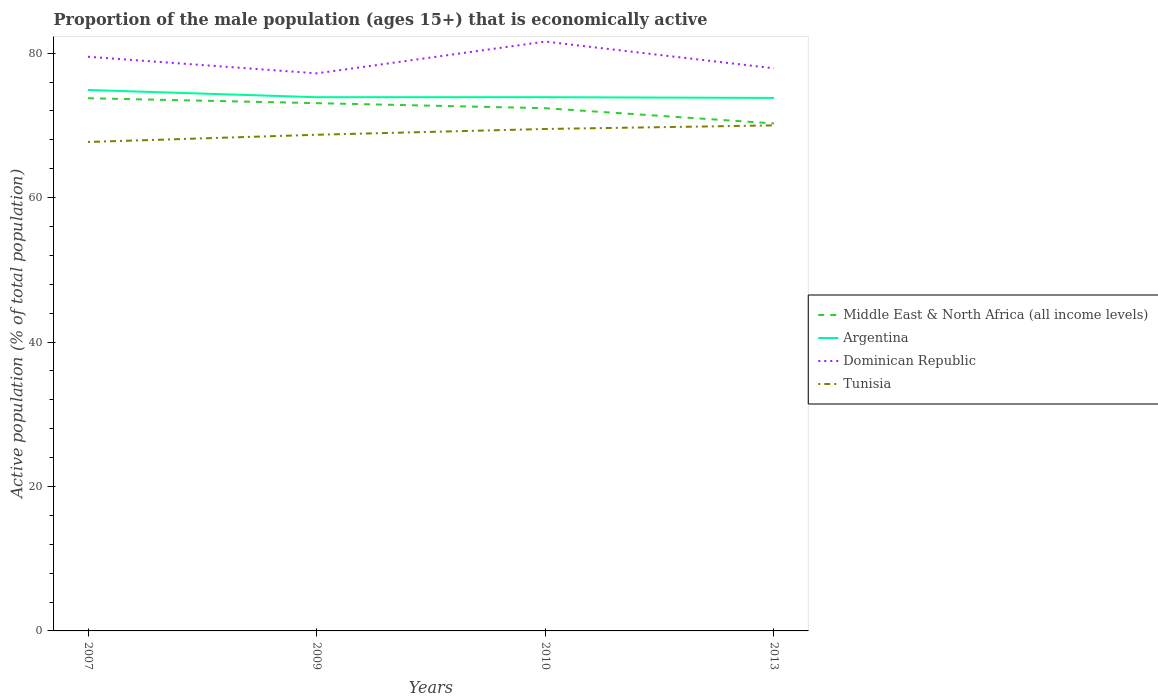How many different coloured lines are there?
Give a very brief answer. 4. Does the line corresponding to Middle East & North Africa (all income levels) intersect with the line corresponding to Tunisia?
Keep it short and to the point. No. Across all years, what is the maximum proportion of the male population that is economically active in Dominican Republic?
Ensure brevity in your answer.  77.2. In which year was the proportion of the male population that is economically active in Middle East & North Africa (all income levels) maximum?
Make the answer very short. 2013. What is the total proportion of the male population that is economically active in Dominican Republic in the graph?
Provide a short and direct response. -2.1. What is the difference between the highest and the second highest proportion of the male population that is economically active in Dominican Republic?
Make the answer very short. 4.4. How many lines are there?
Give a very brief answer. 4. Are the values on the major ticks of Y-axis written in scientific E-notation?
Keep it short and to the point. No. Does the graph contain any zero values?
Ensure brevity in your answer.  No. Does the graph contain grids?
Make the answer very short. No. Where does the legend appear in the graph?
Provide a short and direct response. Center right. How are the legend labels stacked?
Your response must be concise. Vertical. What is the title of the graph?
Keep it short and to the point. Proportion of the male population (ages 15+) that is economically active. Does "Syrian Arab Republic" appear as one of the legend labels in the graph?
Provide a short and direct response. No. What is the label or title of the Y-axis?
Make the answer very short. Active population (% of total population). What is the Active population (% of total population) of Middle East & North Africa (all income levels) in 2007?
Offer a very short reply. 73.76. What is the Active population (% of total population) of Argentina in 2007?
Make the answer very short. 74.9. What is the Active population (% of total population) of Dominican Republic in 2007?
Make the answer very short. 79.5. What is the Active population (% of total population) of Tunisia in 2007?
Make the answer very short. 67.7. What is the Active population (% of total population) in Middle East & North Africa (all income levels) in 2009?
Make the answer very short. 73.08. What is the Active population (% of total population) of Argentina in 2009?
Provide a short and direct response. 73.9. What is the Active population (% of total population) of Dominican Republic in 2009?
Offer a very short reply. 77.2. What is the Active population (% of total population) in Tunisia in 2009?
Provide a short and direct response. 68.7. What is the Active population (% of total population) of Middle East & North Africa (all income levels) in 2010?
Ensure brevity in your answer.  72.38. What is the Active population (% of total population) of Argentina in 2010?
Keep it short and to the point. 73.9. What is the Active population (% of total population) in Dominican Republic in 2010?
Your response must be concise. 81.6. What is the Active population (% of total population) in Tunisia in 2010?
Your response must be concise. 69.5. What is the Active population (% of total population) in Middle East & North Africa (all income levels) in 2013?
Offer a very short reply. 70.27. What is the Active population (% of total population) in Argentina in 2013?
Offer a very short reply. 73.8. What is the Active population (% of total population) in Dominican Republic in 2013?
Your response must be concise. 77.9. Across all years, what is the maximum Active population (% of total population) in Middle East & North Africa (all income levels)?
Your answer should be compact. 73.76. Across all years, what is the maximum Active population (% of total population) of Argentina?
Provide a short and direct response. 74.9. Across all years, what is the maximum Active population (% of total population) in Dominican Republic?
Your response must be concise. 81.6. Across all years, what is the minimum Active population (% of total population) in Middle East & North Africa (all income levels)?
Your answer should be compact. 70.27. Across all years, what is the minimum Active population (% of total population) in Argentina?
Offer a terse response. 73.8. Across all years, what is the minimum Active population (% of total population) of Dominican Republic?
Make the answer very short. 77.2. Across all years, what is the minimum Active population (% of total population) in Tunisia?
Make the answer very short. 67.7. What is the total Active population (% of total population) of Middle East & North Africa (all income levels) in the graph?
Provide a short and direct response. 289.48. What is the total Active population (% of total population) of Argentina in the graph?
Give a very brief answer. 296.5. What is the total Active population (% of total population) of Dominican Republic in the graph?
Keep it short and to the point. 316.2. What is the total Active population (% of total population) in Tunisia in the graph?
Provide a short and direct response. 275.9. What is the difference between the Active population (% of total population) in Middle East & North Africa (all income levels) in 2007 and that in 2009?
Your response must be concise. 0.68. What is the difference between the Active population (% of total population) of Argentina in 2007 and that in 2009?
Provide a succinct answer. 1. What is the difference between the Active population (% of total population) in Dominican Republic in 2007 and that in 2009?
Offer a terse response. 2.3. What is the difference between the Active population (% of total population) in Middle East & North Africa (all income levels) in 2007 and that in 2010?
Give a very brief answer. 1.38. What is the difference between the Active population (% of total population) of Argentina in 2007 and that in 2010?
Your answer should be very brief. 1. What is the difference between the Active population (% of total population) of Dominican Republic in 2007 and that in 2010?
Offer a very short reply. -2.1. What is the difference between the Active population (% of total population) of Middle East & North Africa (all income levels) in 2007 and that in 2013?
Provide a succinct answer. 3.49. What is the difference between the Active population (% of total population) of Argentina in 2007 and that in 2013?
Make the answer very short. 1.1. What is the difference between the Active population (% of total population) in Dominican Republic in 2007 and that in 2013?
Offer a very short reply. 1.6. What is the difference between the Active population (% of total population) in Tunisia in 2007 and that in 2013?
Offer a terse response. -2.3. What is the difference between the Active population (% of total population) of Middle East & North Africa (all income levels) in 2009 and that in 2010?
Provide a succinct answer. 0.7. What is the difference between the Active population (% of total population) in Middle East & North Africa (all income levels) in 2009 and that in 2013?
Your answer should be compact. 2.81. What is the difference between the Active population (% of total population) in Argentina in 2009 and that in 2013?
Provide a short and direct response. 0.1. What is the difference between the Active population (% of total population) of Dominican Republic in 2009 and that in 2013?
Your answer should be very brief. -0.7. What is the difference between the Active population (% of total population) in Tunisia in 2009 and that in 2013?
Keep it short and to the point. -1.3. What is the difference between the Active population (% of total population) of Middle East & North Africa (all income levels) in 2010 and that in 2013?
Offer a very short reply. 2.11. What is the difference between the Active population (% of total population) of Argentina in 2010 and that in 2013?
Your response must be concise. 0.1. What is the difference between the Active population (% of total population) of Dominican Republic in 2010 and that in 2013?
Provide a succinct answer. 3.7. What is the difference between the Active population (% of total population) of Tunisia in 2010 and that in 2013?
Your answer should be very brief. -0.5. What is the difference between the Active population (% of total population) of Middle East & North Africa (all income levels) in 2007 and the Active population (% of total population) of Argentina in 2009?
Keep it short and to the point. -0.14. What is the difference between the Active population (% of total population) of Middle East & North Africa (all income levels) in 2007 and the Active population (% of total population) of Dominican Republic in 2009?
Give a very brief answer. -3.44. What is the difference between the Active population (% of total population) of Middle East & North Africa (all income levels) in 2007 and the Active population (% of total population) of Tunisia in 2009?
Provide a succinct answer. 5.06. What is the difference between the Active population (% of total population) of Argentina in 2007 and the Active population (% of total population) of Dominican Republic in 2009?
Your answer should be very brief. -2.3. What is the difference between the Active population (% of total population) in Argentina in 2007 and the Active population (% of total population) in Tunisia in 2009?
Keep it short and to the point. 6.2. What is the difference between the Active population (% of total population) in Dominican Republic in 2007 and the Active population (% of total population) in Tunisia in 2009?
Ensure brevity in your answer.  10.8. What is the difference between the Active population (% of total population) in Middle East & North Africa (all income levels) in 2007 and the Active population (% of total population) in Argentina in 2010?
Your answer should be very brief. -0.14. What is the difference between the Active population (% of total population) of Middle East & North Africa (all income levels) in 2007 and the Active population (% of total population) of Dominican Republic in 2010?
Offer a very short reply. -7.84. What is the difference between the Active population (% of total population) of Middle East & North Africa (all income levels) in 2007 and the Active population (% of total population) of Tunisia in 2010?
Provide a succinct answer. 4.26. What is the difference between the Active population (% of total population) in Dominican Republic in 2007 and the Active population (% of total population) in Tunisia in 2010?
Provide a succinct answer. 10. What is the difference between the Active population (% of total population) in Middle East & North Africa (all income levels) in 2007 and the Active population (% of total population) in Argentina in 2013?
Give a very brief answer. -0.04. What is the difference between the Active population (% of total population) in Middle East & North Africa (all income levels) in 2007 and the Active population (% of total population) in Dominican Republic in 2013?
Keep it short and to the point. -4.14. What is the difference between the Active population (% of total population) of Middle East & North Africa (all income levels) in 2007 and the Active population (% of total population) of Tunisia in 2013?
Give a very brief answer. 3.76. What is the difference between the Active population (% of total population) of Argentina in 2007 and the Active population (% of total population) of Tunisia in 2013?
Give a very brief answer. 4.9. What is the difference between the Active population (% of total population) of Dominican Republic in 2007 and the Active population (% of total population) of Tunisia in 2013?
Make the answer very short. 9.5. What is the difference between the Active population (% of total population) in Middle East & North Africa (all income levels) in 2009 and the Active population (% of total population) in Argentina in 2010?
Provide a short and direct response. -0.82. What is the difference between the Active population (% of total population) of Middle East & North Africa (all income levels) in 2009 and the Active population (% of total population) of Dominican Republic in 2010?
Keep it short and to the point. -8.52. What is the difference between the Active population (% of total population) of Middle East & North Africa (all income levels) in 2009 and the Active population (% of total population) of Tunisia in 2010?
Provide a short and direct response. 3.58. What is the difference between the Active population (% of total population) in Argentina in 2009 and the Active population (% of total population) in Dominican Republic in 2010?
Your answer should be very brief. -7.7. What is the difference between the Active population (% of total population) of Argentina in 2009 and the Active population (% of total population) of Tunisia in 2010?
Provide a short and direct response. 4.4. What is the difference between the Active population (% of total population) of Middle East & North Africa (all income levels) in 2009 and the Active population (% of total population) of Argentina in 2013?
Keep it short and to the point. -0.72. What is the difference between the Active population (% of total population) in Middle East & North Africa (all income levels) in 2009 and the Active population (% of total population) in Dominican Republic in 2013?
Make the answer very short. -4.82. What is the difference between the Active population (% of total population) in Middle East & North Africa (all income levels) in 2009 and the Active population (% of total population) in Tunisia in 2013?
Ensure brevity in your answer.  3.08. What is the difference between the Active population (% of total population) in Argentina in 2009 and the Active population (% of total population) in Dominican Republic in 2013?
Keep it short and to the point. -4. What is the difference between the Active population (% of total population) of Middle East & North Africa (all income levels) in 2010 and the Active population (% of total population) of Argentina in 2013?
Your response must be concise. -1.42. What is the difference between the Active population (% of total population) of Middle East & North Africa (all income levels) in 2010 and the Active population (% of total population) of Dominican Republic in 2013?
Offer a very short reply. -5.52. What is the difference between the Active population (% of total population) in Middle East & North Africa (all income levels) in 2010 and the Active population (% of total population) in Tunisia in 2013?
Ensure brevity in your answer.  2.38. What is the difference between the Active population (% of total population) in Argentina in 2010 and the Active population (% of total population) in Dominican Republic in 2013?
Keep it short and to the point. -4. What is the difference between the Active population (% of total population) in Argentina in 2010 and the Active population (% of total population) in Tunisia in 2013?
Provide a succinct answer. 3.9. What is the difference between the Active population (% of total population) in Dominican Republic in 2010 and the Active population (% of total population) in Tunisia in 2013?
Your response must be concise. 11.6. What is the average Active population (% of total population) in Middle East & North Africa (all income levels) per year?
Your response must be concise. 72.37. What is the average Active population (% of total population) of Argentina per year?
Offer a very short reply. 74.12. What is the average Active population (% of total population) of Dominican Republic per year?
Keep it short and to the point. 79.05. What is the average Active population (% of total population) in Tunisia per year?
Offer a very short reply. 68.97. In the year 2007, what is the difference between the Active population (% of total population) of Middle East & North Africa (all income levels) and Active population (% of total population) of Argentina?
Offer a terse response. -1.14. In the year 2007, what is the difference between the Active population (% of total population) in Middle East & North Africa (all income levels) and Active population (% of total population) in Dominican Republic?
Your response must be concise. -5.74. In the year 2007, what is the difference between the Active population (% of total population) in Middle East & North Africa (all income levels) and Active population (% of total population) in Tunisia?
Your answer should be very brief. 6.06. In the year 2007, what is the difference between the Active population (% of total population) of Argentina and Active population (% of total population) of Tunisia?
Your answer should be compact. 7.2. In the year 2007, what is the difference between the Active population (% of total population) in Dominican Republic and Active population (% of total population) in Tunisia?
Offer a very short reply. 11.8. In the year 2009, what is the difference between the Active population (% of total population) of Middle East & North Africa (all income levels) and Active population (% of total population) of Argentina?
Your response must be concise. -0.82. In the year 2009, what is the difference between the Active population (% of total population) in Middle East & North Africa (all income levels) and Active population (% of total population) in Dominican Republic?
Provide a succinct answer. -4.12. In the year 2009, what is the difference between the Active population (% of total population) in Middle East & North Africa (all income levels) and Active population (% of total population) in Tunisia?
Provide a short and direct response. 4.38. In the year 2009, what is the difference between the Active population (% of total population) of Argentina and Active population (% of total population) of Tunisia?
Provide a succinct answer. 5.2. In the year 2009, what is the difference between the Active population (% of total population) in Dominican Republic and Active population (% of total population) in Tunisia?
Give a very brief answer. 8.5. In the year 2010, what is the difference between the Active population (% of total population) of Middle East & North Africa (all income levels) and Active population (% of total population) of Argentina?
Your response must be concise. -1.52. In the year 2010, what is the difference between the Active population (% of total population) of Middle East & North Africa (all income levels) and Active population (% of total population) of Dominican Republic?
Offer a terse response. -9.22. In the year 2010, what is the difference between the Active population (% of total population) in Middle East & North Africa (all income levels) and Active population (% of total population) in Tunisia?
Offer a very short reply. 2.88. In the year 2010, what is the difference between the Active population (% of total population) of Argentina and Active population (% of total population) of Dominican Republic?
Your response must be concise. -7.7. In the year 2010, what is the difference between the Active population (% of total population) in Argentina and Active population (% of total population) in Tunisia?
Provide a succinct answer. 4.4. In the year 2013, what is the difference between the Active population (% of total population) of Middle East & North Africa (all income levels) and Active population (% of total population) of Argentina?
Provide a short and direct response. -3.53. In the year 2013, what is the difference between the Active population (% of total population) in Middle East & North Africa (all income levels) and Active population (% of total population) in Dominican Republic?
Provide a succinct answer. -7.63. In the year 2013, what is the difference between the Active population (% of total population) of Middle East & North Africa (all income levels) and Active population (% of total population) of Tunisia?
Your answer should be very brief. 0.27. In the year 2013, what is the difference between the Active population (% of total population) in Argentina and Active population (% of total population) in Dominican Republic?
Offer a very short reply. -4.1. What is the ratio of the Active population (% of total population) of Middle East & North Africa (all income levels) in 2007 to that in 2009?
Give a very brief answer. 1.01. What is the ratio of the Active population (% of total population) of Argentina in 2007 to that in 2009?
Keep it short and to the point. 1.01. What is the ratio of the Active population (% of total population) in Dominican Republic in 2007 to that in 2009?
Offer a very short reply. 1.03. What is the ratio of the Active population (% of total population) in Tunisia in 2007 to that in 2009?
Offer a terse response. 0.99. What is the ratio of the Active population (% of total population) of Middle East & North Africa (all income levels) in 2007 to that in 2010?
Offer a terse response. 1.02. What is the ratio of the Active population (% of total population) in Argentina in 2007 to that in 2010?
Offer a very short reply. 1.01. What is the ratio of the Active population (% of total population) in Dominican Republic in 2007 to that in 2010?
Offer a very short reply. 0.97. What is the ratio of the Active population (% of total population) in Tunisia in 2007 to that in 2010?
Keep it short and to the point. 0.97. What is the ratio of the Active population (% of total population) in Middle East & North Africa (all income levels) in 2007 to that in 2013?
Ensure brevity in your answer.  1.05. What is the ratio of the Active population (% of total population) in Argentina in 2007 to that in 2013?
Ensure brevity in your answer.  1.01. What is the ratio of the Active population (% of total population) of Dominican Republic in 2007 to that in 2013?
Keep it short and to the point. 1.02. What is the ratio of the Active population (% of total population) of Tunisia in 2007 to that in 2013?
Give a very brief answer. 0.97. What is the ratio of the Active population (% of total population) in Middle East & North Africa (all income levels) in 2009 to that in 2010?
Your answer should be very brief. 1.01. What is the ratio of the Active population (% of total population) of Argentina in 2009 to that in 2010?
Provide a succinct answer. 1. What is the ratio of the Active population (% of total population) of Dominican Republic in 2009 to that in 2010?
Ensure brevity in your answer.  0.95. What is the ratio of the Active population (% of total population) in Middle East & North Africa (all income levels) in 2009 to that in 2013?
Your answer should be very brief. 1.04. What is the ratio of the Active population (% of total population) of Argentina in 2009 to that in 2013?
Provide a succinct answer. 1. What is the ratio of the Active population (% of total population) in Dominican Republic in 2009 to that in 2013?
Offer a terse response. 0.99. What is the ratio of the Active population (% of total population) of Tunisia in 2009 to that in 2013?
Offer a very short reply. 0.98. What is the ratio of the Active population (% of total population) in Middle East & North Africa (all income levels) in 2010 to that in 2013?
Offer a terse response. 1.03. What is the ratio of the Active population (% of total population) of Argentina in 2010 to that in 2013?
Provide a short and direct response. 1. What is the ratio of the Active population (% of total population) of Dominican Republic in 2010 to that in 2013?
Make the answer very short. 1.05. What is the ratio of the Active population (% of total population) in Tunisia in 2010 to that in 2013?
Offer a terse response. 0.99. What is the difference between the highest and the second highest Active population (% of total population) of Middle East & North Africa (all income levels)?
Your response must be concise. 0.68. What is the difference between the highest and the lowest Active population (% of total population) of Middle East & North Africa (all income levels)?
Offer a very short reply. 3.49. What is the difference between the highest and the lowest Active population (% of total population) in Dominican Republic?
Provide a short and direct response. 4.4. What is the difference between the highest and the lowest Active population (% of total population) of Tunisia?
Your response must be concise. 2.3. 